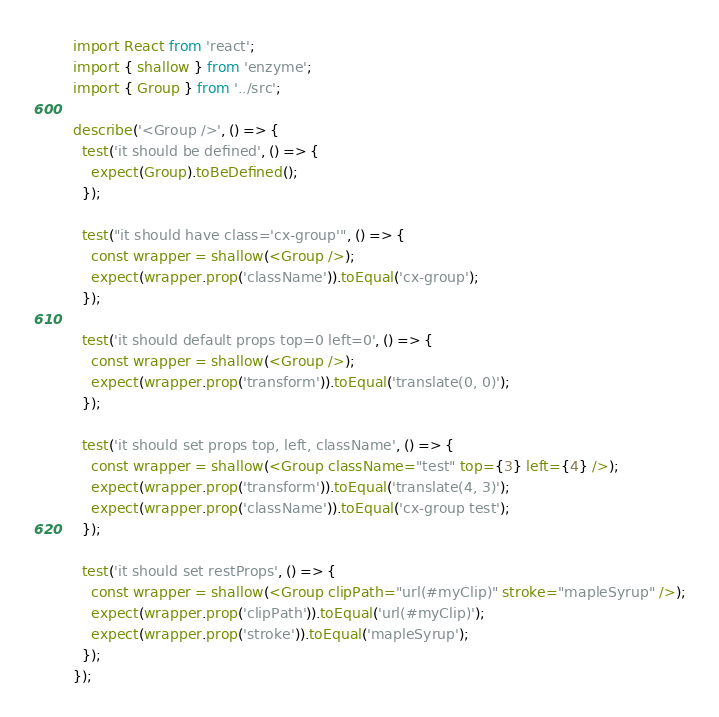Convert code to text. <code><loc_0><loc_0><loc_500><loc_500><_JavaScript_>import React from 'react';
import { shallow } from 'enzyme';
import { Group } from '../src';

describe('<Group />', () => {
  test('it should be defined', () => {
    expect(Group).toBeDefined();
  });

  test("it should have class='cx-group'", () => {
    const wrapper = shallow(<Group />);
    expect(wrapper.prop('className')).toEqual('cx-group');
  });

  test('it should default props top=0 left=0', () => {
    const wrapper = shallow(<Group />);
    expect(wrapper.prop('transform')).toEqual('translate(0, 0)');
  });

  test('it should set props top, left, className', () => {
    const wrapper = shallow(<Group className="test" top={3} left={4} />);
    expect(wrapper.prop('transform')).toEqual('translate(4, 3)');
    expect(wrapper.prop('className')).toEqual('cx-group test');
  });

  test('it should set restProps', () => {
    const wrapper = shallow(<Group clipPath="url(#myClip)" stroke="mapleSyrup" />);
    expect(wrapper.prop('clipPath')).toEqual('url(#myClip)');
    expect(wrapper.prop('stroke')).toEqual('mapleSyrup');
  });
});
</code> 